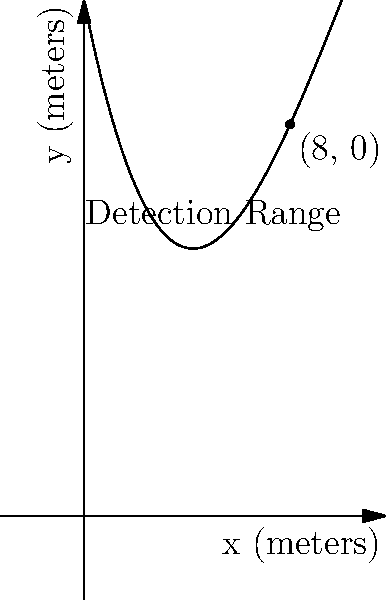A high-tech facility's security system has a detection range modeled by the polynomial function $f(x) = -0.025x^3 + 0.75x^2 - 5x + 20$, where $x$ is the distance from the facility in meters and $f(x)$ is the detection height in meters. At what distance from the facility does the detection range reach ground level (i.e., $f(x) = 0$)? To find where the detection range reaches ground level, we need to solve the equation:

$$-0.025x^3 + 0.75x^2 - 5x + 20 = 0$$

This is a cubic equation, which can be challenging to solve by hand. However, we can observe from the graph that the solution is close to $x = 8$.

Let's verify this by plugging in $x = 8$:

$$\begin{align}
f(8) &= -0.025(8^3) + 0.75(8^2) - 5(8) + 20 \\
&= -0.025(512) + 0.75(64) - 40 + 20 \\
&= -12.8 + 48 - 40 + 20 \\
&= 15.2
\end{align}$$

Now, let's try $x = 8.06$:

$$\begin{align}
f(8.06) &≈ -0.025(522.433) + 0.75(64.964) - 5(8.06) + 20 \\
&≈ -13.061 + 48.723 - 40.3 + 20 \\
&≈ 0.002
\end{align}$$

This is very close to zero. Given the context of the problem, rounding to 8 meters is a reasonable approximation.
Answer: 8 meters 